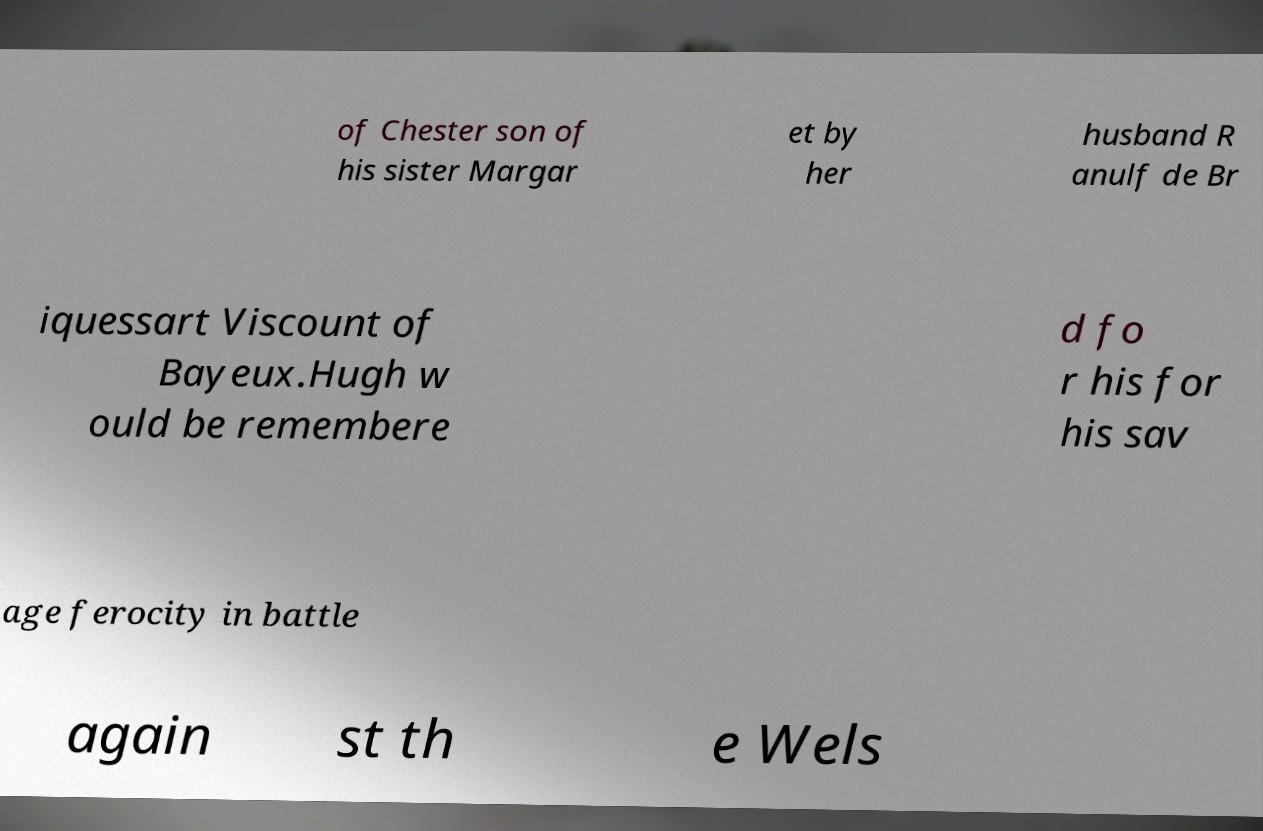There's text embedded in this image that I need extracted. Can you transcribe it verbatim? of Chester son of his sister Margar et by her husband R anulf de Br iquessart Viscount of Bayeux.Hugh w ould be remembere d fo r his for his sav age ferocity in battle again st th e Wels 